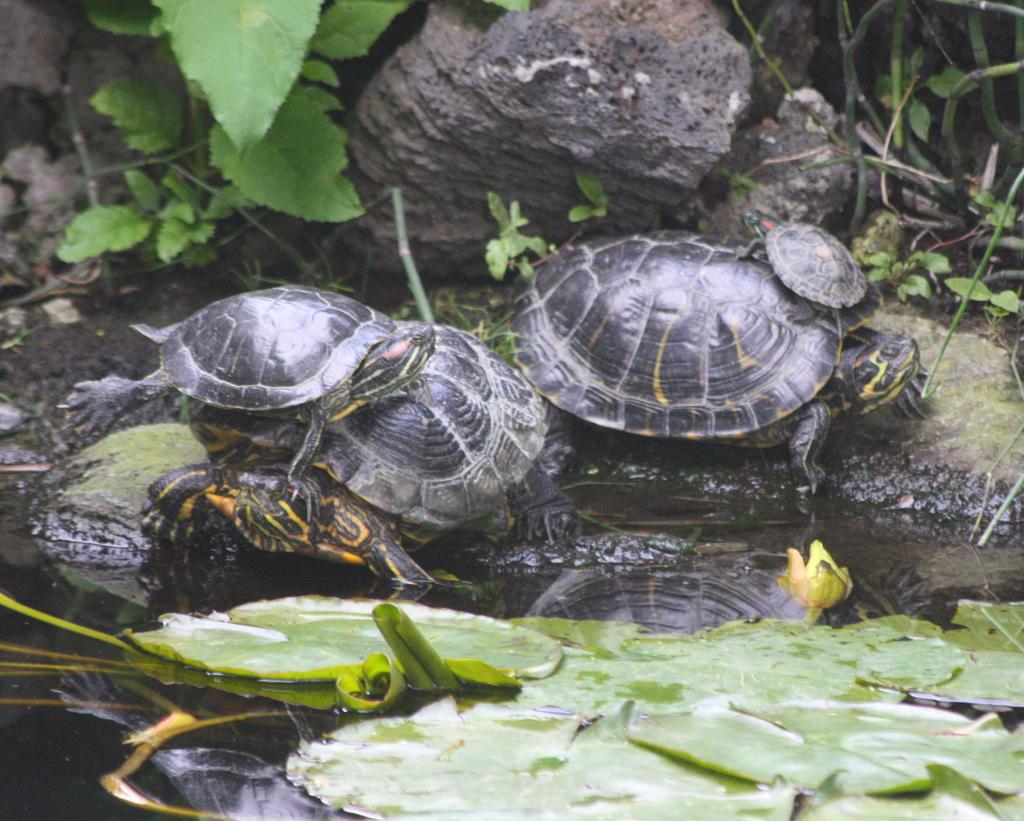What type of living organisms can be seen in the image? Plants and turtles are visible in the image. What can be found at the top of the image? There are rocks at the top of the image. What is floating on the surface of the water in the image? There are leaves on the surface of the water in the image. What type of snake can be seen slithering through the hospital in the image? There is no snake or hospital present in the image. How many eggs are visible in the image? There are no eggs visible in the image. 